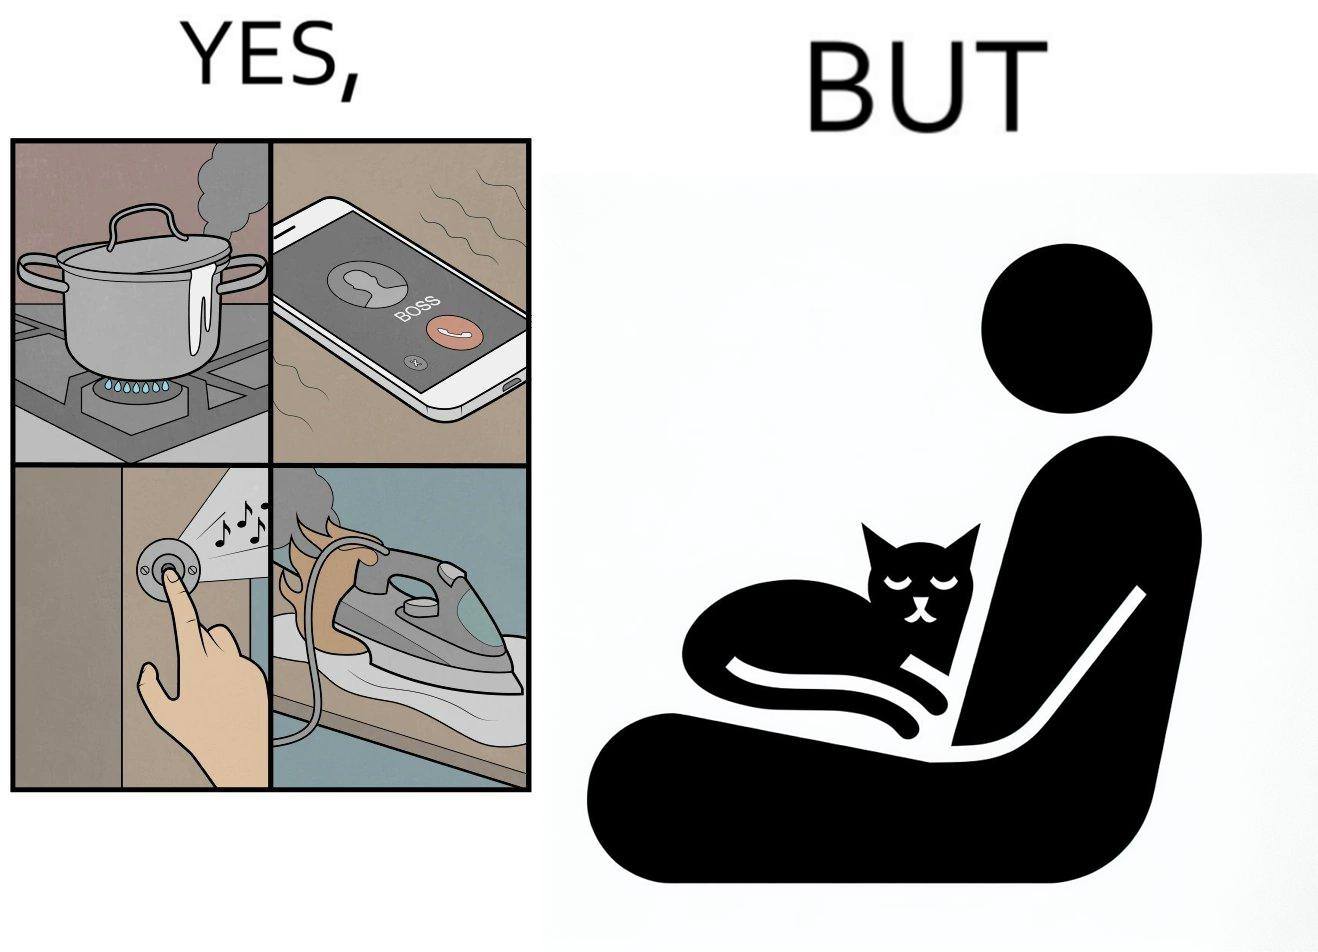What do you see in each half of this image? In the left part of the image: Image depicts chaos in a household with overflowing pots, ringing phone, door bell going off, and the iron burning clothes In the right part of the image: a cat sleeping on the lap of a person 